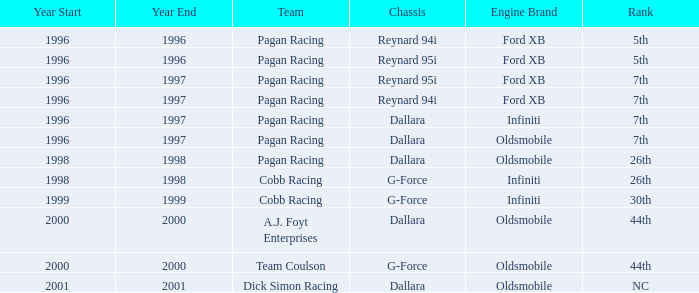What engine was used in 1999? Infiniti. 